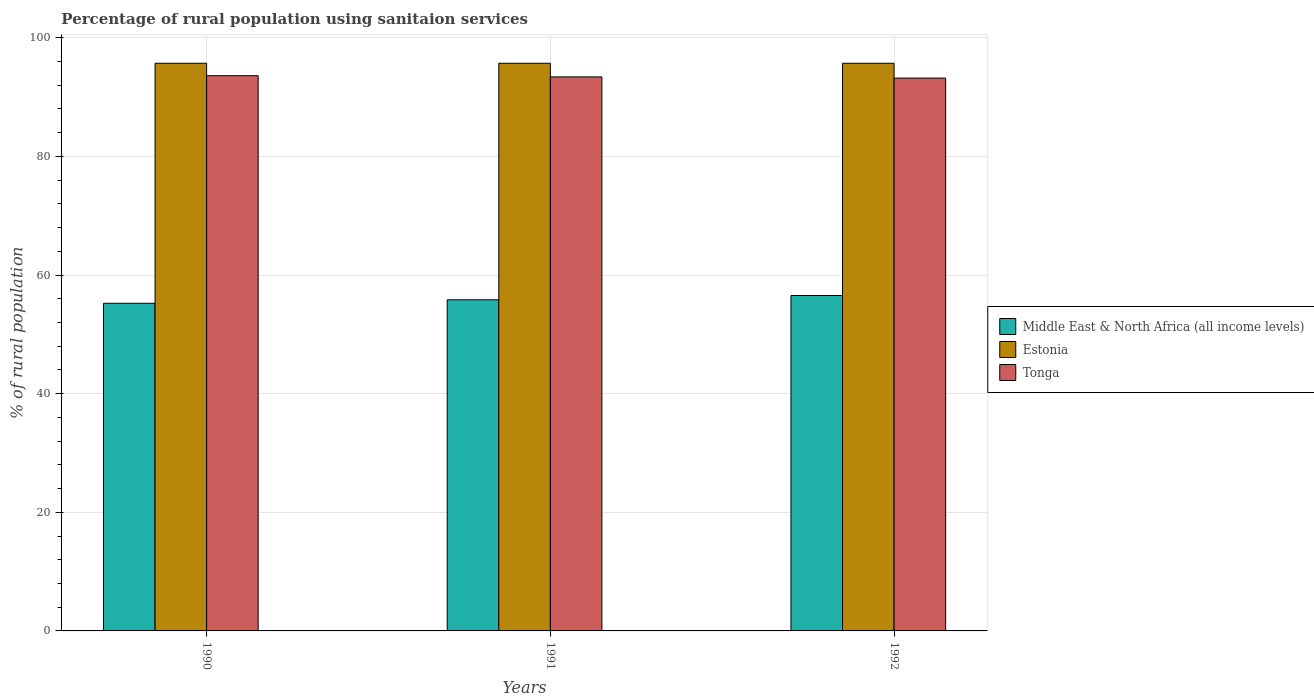How many different coloured bars are there?
Your answer should be very brief. 3. How many groups of bars are there?
Offer a terse response. 3. What is the label of the 2nd group of bars from the left?
Ensure brevity in your answer.  1991. What is the percentage of rural population using sanitaion services in Tonga in 1991?
Offer a terse response. 93.4. Across all years, what is the maximum percentage of rural population using sanitaion services in Middle East & North Africa (all income levels)?
Your answer should be very brief. 56.55. Across all years, what is the minimum percentage of rural population using sanitaion services in Middle East & North Africa (all income levels)?
Ensure brevity in your answer.  55.23. In which year was the percentage of rural population using sanitaion services in Middle East & North Africa (all income levels) maximum?
Keep it short and to the point. 1992. In which year was the percentage of rural population using sanitaion services in Middle East & North Africa (all income levels) minimum?
Offer a very short reply. 1990. What is the total percentage of rural population using sanitaion services in Middle East & North Africa (all income levels) in the graph?
Your answer should be very brief. 167.6. What is the difference between the percentage of rural population using sanitaion services in Middle East & North Africa (all income levels) in 1991 and the percentage of rural population using sanitaion services in Tonga in 1990?
Ensure brevity in your answer.  -37.78. What is the average percentage of rural population using sanitaion services in Middle East & North Africa (all income levels) per year?
Make the answer very short. 55.87. Is the percentage of rural population using sanitaion services in Middle East & North Africa (all income levels) in 1990 less than that in 1991?
Your answer should be very brief. Yes. Is the difference between the percentage of rural population using sanitaion services in Tonga in 1990 and 1991 greater than the difference between the percentage of rural population using sanitaion services in Estonia in 1990 and 1991?
Your answer should be compact. Yes. What is the difference between the highest and the second highest percentage of rural population using sanitaion services in Middle East & North Africa (all income levels)?
Offer a very short reply. 0.72. What is the difference between the highest and the lowest percentage of rural population using sanitaion services in Tonga?
Offer a very short reply. 0.4. In how many years, is the percentage of rural population using sanitaion services in Tonga greater than the average percentage of rural population using sanitaion services in Tonga taken over all years?
Offer a very short reply. 2. Is the sum of the percentage of rural population using sanitaion services in Estonia in 1990 and 1992 greater than the maximum percentage of rural population using sanitaion services in Tonga across all years?
Your response must be concise. Yes. What does the 1st bar from the left in 1990 represents?
Provide a short and direct response. Middle East & North Africa (all income levels). What does the 3rd bar from the right in 1992 represents?
Ensure brevity in your answer.  Middle East & North Africa (all income levels). Are all the bars in the graph horizontal?
Your answer should be very brief. No. What is the difference between two consecutive major ticks on the Y-axis?
Ensure brevity in your answer.  20. Does the graph contain any zero values?
Keep it short and to the point. No. Does the graph contain grids?
Make the answer very short. Yes. How many legend labels are there?
Offer a terse response. 3. How are the legend labels stacked?
Provide a short and direct response. Vertical. What is the title of the graph?
Make the answer very short. Percentage of rural population using sanitaion services. What is the label or title of the X-axis?
Make the answer very short. Years. What is the label or title of the Y-axis?
Offer a very short reply. % of rural population. What is the % of rural population in Middle East & North Africa (all income levels) in 1990?
Offer a very short reply. 55.23. What is the % of rural population in Estonia in 1990?
Ensure brevity in your answer.  95.7. What is the % of rural population in Tonga in 1990?
Give a very brief answer. 93.6. What is the % of rural population of Middle East & North Africa (all income levels) in 1991?
Provide a short and direct response. 55.82. What is the % of rural population of Estonia in 1991?
Provide a short and direct response. 95.7. What is the % of rural population of Tonga in 1991?
Keep it short and to the point. 93.4. What is the % of rural population in Middle East & North Africa (all income levels) in 1992?
Give a very brief answer. 56.55. What is the % of rural population in Estonia in 1992?
Provide a succinct answer. 95.7. What is the % of rural population of Tonga in 1992?
Provide a succinct answer. 93.2. Across all years, what is the maximum % of rural population in Middle East & North Africa (all income levels)?
Make the answer very short. 56.55. Across all years, what is the maximum % of rural population of Estonia?
Offer a very short reply. 95.7. Across all years, what is the maximum % of rural population of Tonga?
Your answer should be very brief. 93.6. Across all years, what is the minimum % of rural population in Middle East & North Africa (all income levels)?
Provide a short and direct response. 55.23. Across all years, what is the minimum % of rural population in Estonia?
Keep it short and to the point. 95.7. Across all years, what is the minimum % of rural population of Tonga?
Give a very brief answer. 93.2. What is the total % of rural population in Middle East & North Africa (all income levels) in the graph?
Give a very brief answer. 167.6. What is the total % of rural population in Estonia in the graph?
Provide a short and direct response. 287.1. What is the total % of rural population of Tonga in the graph?
Your answer should be compact. 280.2. What is the difference between the % of rural population in Middle East & North Africa (all income levels) in 1990 and that in 1991?
Ensure brevity in your answer.  -0.59. What is the difference between the % of rural population in Estonia in 1990 and that in 1991?
Ensure brevity in your answer.  0. What is the difference between the % of rural population in Tonga in 1990 and that in 1991?
Your response must be concise. 0.2. What is the difference between the % of rural population in Middle East & North Africa (all income levels) in 1990 and that in 1992?
Your answer should be compact. -1.31. What is the difference between the % of rural population of Estonia in 1990 and that in 1992?
Make the answer very short. 0. What is the difference between the % of rural population in Middle East & North Africa (all income levels) in 1991 and that in 1992?
Give a very brief answer. -0.72. What is the difference between the % of rural population in Middle East & North Africa (all income levels) in 1990 and the % of rural population in Estonia in 1991?
Give a very brief answer. -40.47. What is the difference between the % of rural population in Middle East & North Africa (all income levels) in 1990 and the % of rural population in Tonga in 1991?
Your response must be concise. -38.17. What is the difference between the % of rural population in Middle East & North Africa (all income levels) in 1990 and the % of rural population in Estonia in 1992?
Your response must be concise. -40.47. What is the difference between the % of rural population in Middle East & North Africa (all income levels) in 1990 and the % of rural population in Tonga in 1992?
Offer a very short reply. -37.97. What is the difference between the % of rural population of Middle East & North Africa (all income levels) in 1991 and the % of rural population of Estonia in 1992?
Your response must be concise. -39.88. What is the difference between the % of rural population of Middle East & North Africa (all income levels) in 1991 and the % of rural population of Tonga in 1992?
Make the answer very short. -37.38. What is the difference between the % of rural population in Estonia in 1991 and the % of rural population in Tonga in 1992?
Offer a very short reply. 2.5. What is the average % of rural population of Middle East & North Africa (all income levels) per year?
Ensure brevity in your answer.  55.87. What is the average % of rural population of Estonia per year?
Your answer should be compact. 95.7. What is the average % of rural population of Tonga per year?
Your response must be concise. 93.4. In the year 1990, what is the difference between the % of rural population of Middle East & North Africa (all income levels) and % of rural population of Estonia?
Give a very brief answer. -40.47. In the year 1990, what is the difference between the % of rural population in Middle East & North Africa (all income levels) and % of rural population in Tonga?
Provide a short and direct response. -38.37. In the year 1990, what is the difference between the % of rural population of Estonia and % of rural population of Tonga?
Keep it short and to the point. 2.1. In the year 1991, what is the difference between the % of rural population in Middle East & North Africa (all income levels) and % of rural population in Estonia?
Give a very brief answer. -39.88. In the year 1991, what is the difference between the % of rural population of Middle East & North Africa (all income levels) and % of rural population of Tonga?
Provide a short and direct response. -37.58. In the year 1992, what is the difference between the % of rural population of Middle East & North Africa (all income levels) and % of rural population of Estonia?
Make the answer very short. -39.15. In the year 1992, what is the difference between the % of rural population of Middle East & North Africa (all income levels) and % of rural population of Tonga?
Ensure brevity in your answer.  -36.65. What is the ratio of the % of rural population of Middle East & North Africa (all income levels) in 1990 to that in 1992?
Provide a short and direct response. 0.98. What is the ratio of the % of rural population in Estonia in 1990 to that in 1992?
Make the answer very short. 1. What is the ratio of the % of rural population in Tonga in 1990 to that in 1992?
Give a very brief answer. 1. What is the ratio of the % of rural population of Middle East & North Africa (all income levels) in 1991 to that in 1992?
Make the answer very short. 0.99. What is the ratio of the % of rural population in Tonga in 1991 to that in 1992?
Keep it short and to the point. 1. What is the difference between the highest and the second highest % of rural population in Middle East & North Africa (all income levels)?
Offer a terse response. 0.72. What is the difference between the highest and the second highest % of rural population in Estonia?
Your response must be concise. 0. What is the difference between the highest and the lowest % of rural population of Middle East & North Africa (all income levels)?
Provide a succinct answer. 1.31. What is the difference between the highest and the lowest % of rural population in Estonia?
Provide a short and direct response. 0. What is the difference between the highest and the lowest % of rural population in Tonga?
Your answer should be very brief. 0.4. 